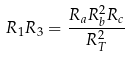<formula> <loc_0><loc_0><loc_500><loc_500>R _ { 1 } R _ { 3 } = \frac { R _ { a } R _ { b } ^ { 2 } R _ { c } } { R _ { T } ^ { 2 } }</formula> 